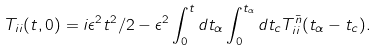Convert formula to latex. <formula><loc_0><loc_0><loc_500><loc_500>T _ { i i } ( t , 0 ) = i \epsilon ^ { 2 } t ^ { 2 } / 2 - \epsilon ^ { 2 } \int _ { 0 } ^ { t } d t _ { \alpha } \int _ { 0 } ^ { t _ { \alpha } } d t _ { c } T ^ { \bar { n } } _ { i i } ( t _ { \alpha } - t _ { c } ) .</formula> 